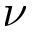<formula> <loc_0><loc_0><loc_500><loc_500>\nu</formula> 